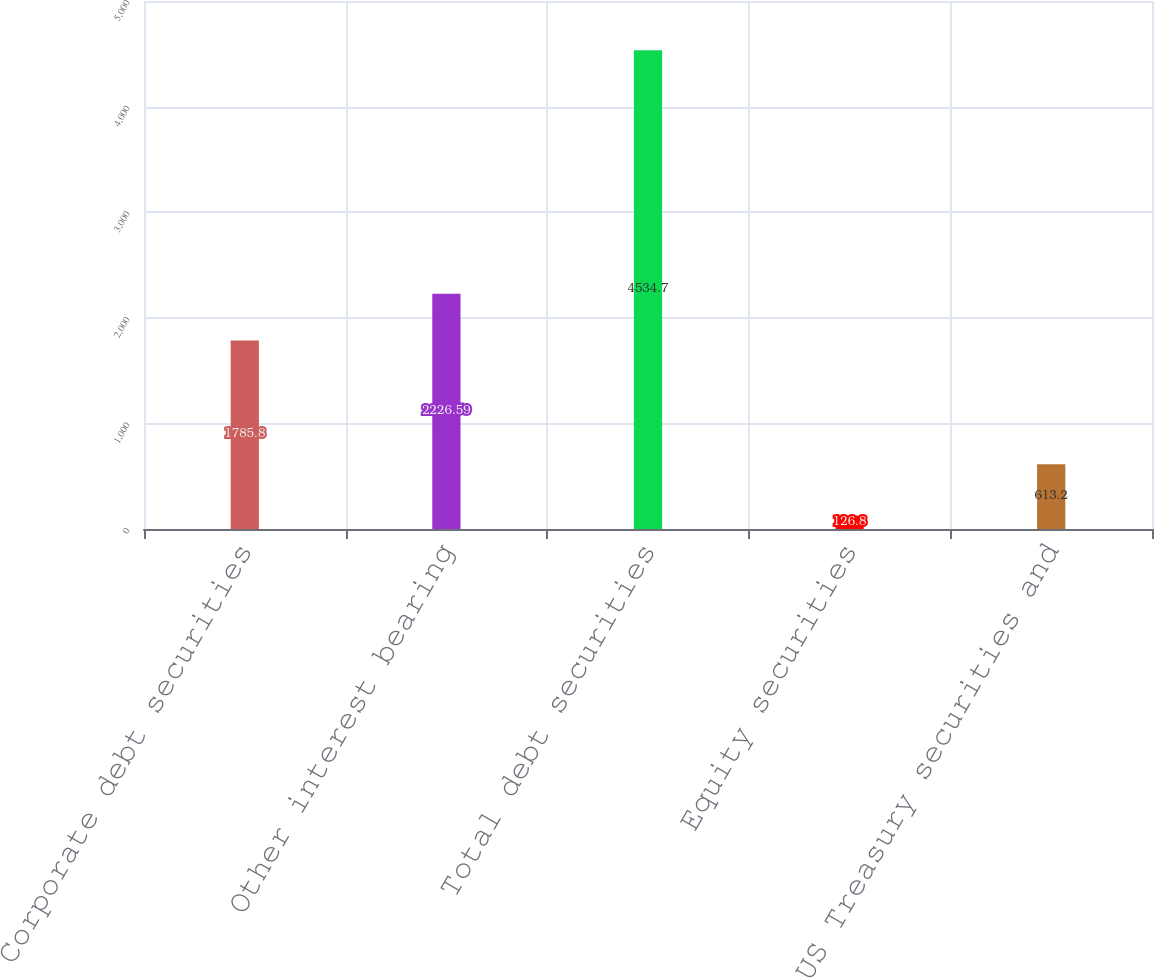<chart> <loc_0><loc_0><loc_500><loc_500><bar_chart><fcel>Corporate debt securities<fcel>Other interest bearing<fcel>Total debt securities<fcel>Equity securities<fcel>US Treasury securities and<nl><fcel>1785.8<fcel>2226.59<fcel>4534.7<fcel>126.8<fcel>613.2<nl></chart> 